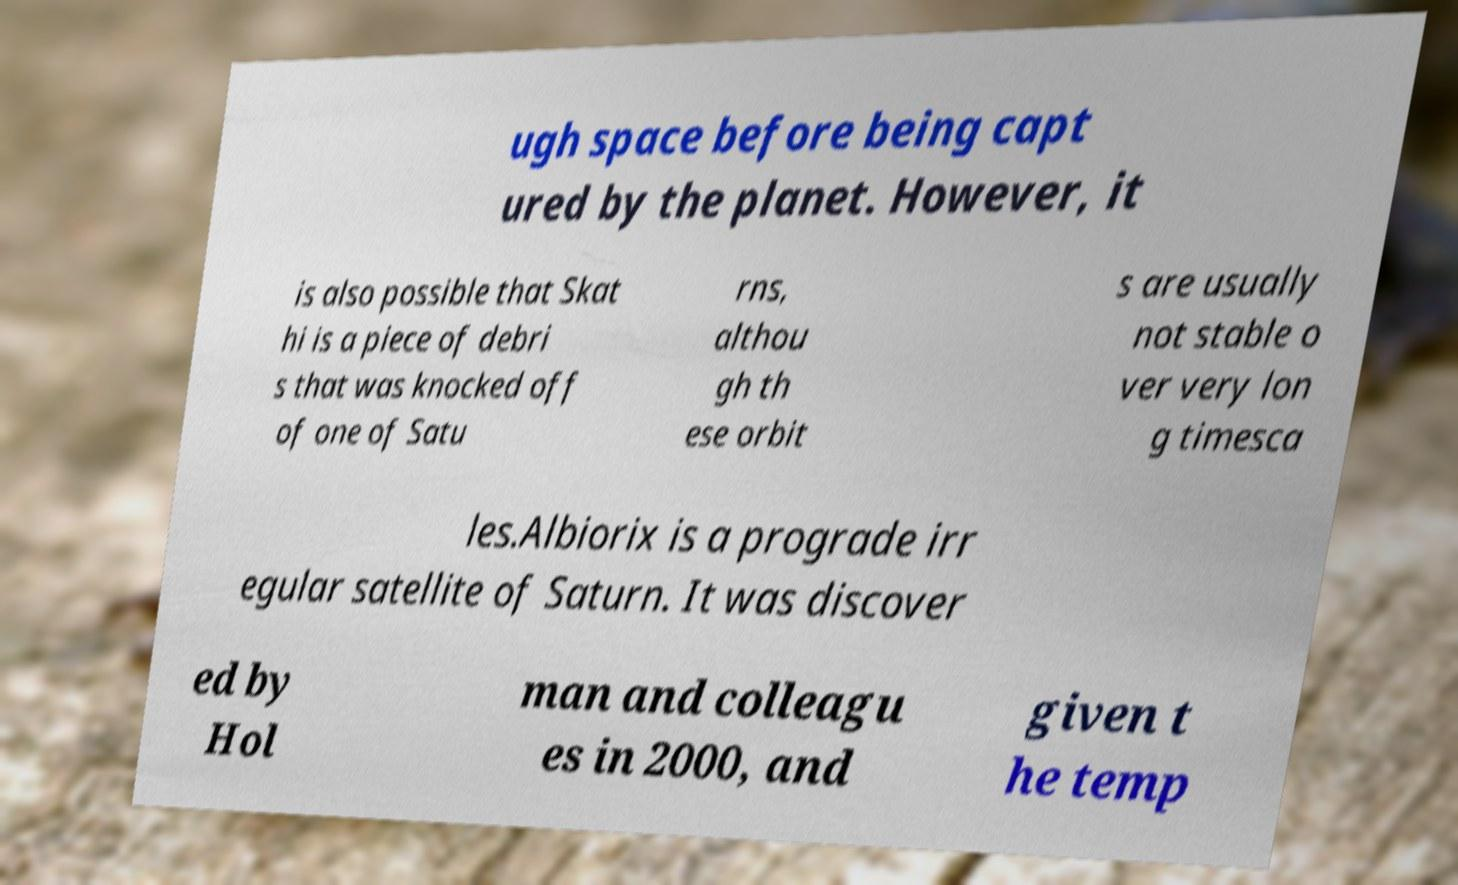Can you read and provide the text displayed in the image?This photo seems to have some interesting text. Can you extract and type it out for me? ugh space before being capt ured by the planet. However, it is also possible that Skat hi is a piece of debri s that was knocked off of one of Satu rns, althou gh th ese orbit s are usually not stable o ver very lon g timesca les.Albiorix is a prograde irr egular satellite of Saturn. It was discover ed by Hol man and colleagu es in 2000, and given t he temp 